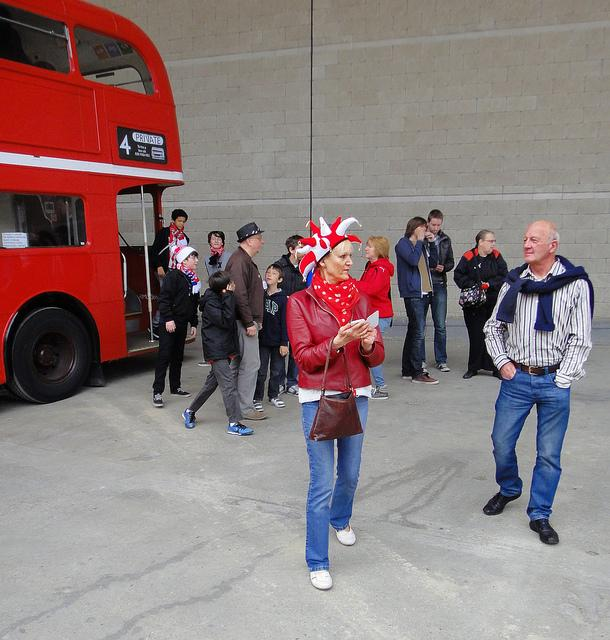What activity do the persons near the bus take part in?

Choices:
A) harvest
B) tourism
C) sales
D) marketing tourism 